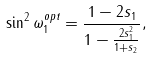Convert formula to latex. <formula><loc_0><loc_0><loc_500><loc_500>\sin ^ { 2 } \omega _ { 1 } ^ { o p t } = \frac { 1 - 2 s _ { 1 } } { 1 - \frac { 2 s _ { 1 } ^ { 2 } } { 1 + s _ { 2 } } } ,</formula> 